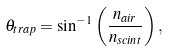Convert formula to latex. <formula><loc_0><loc_0><loc_500><loc_500>\theta _ { t r a p } = \sin ^ { - 1 } \left ( { \frac { n _ { a i r } } { n _ { s c i n t } } } \right ) ,</formula> 